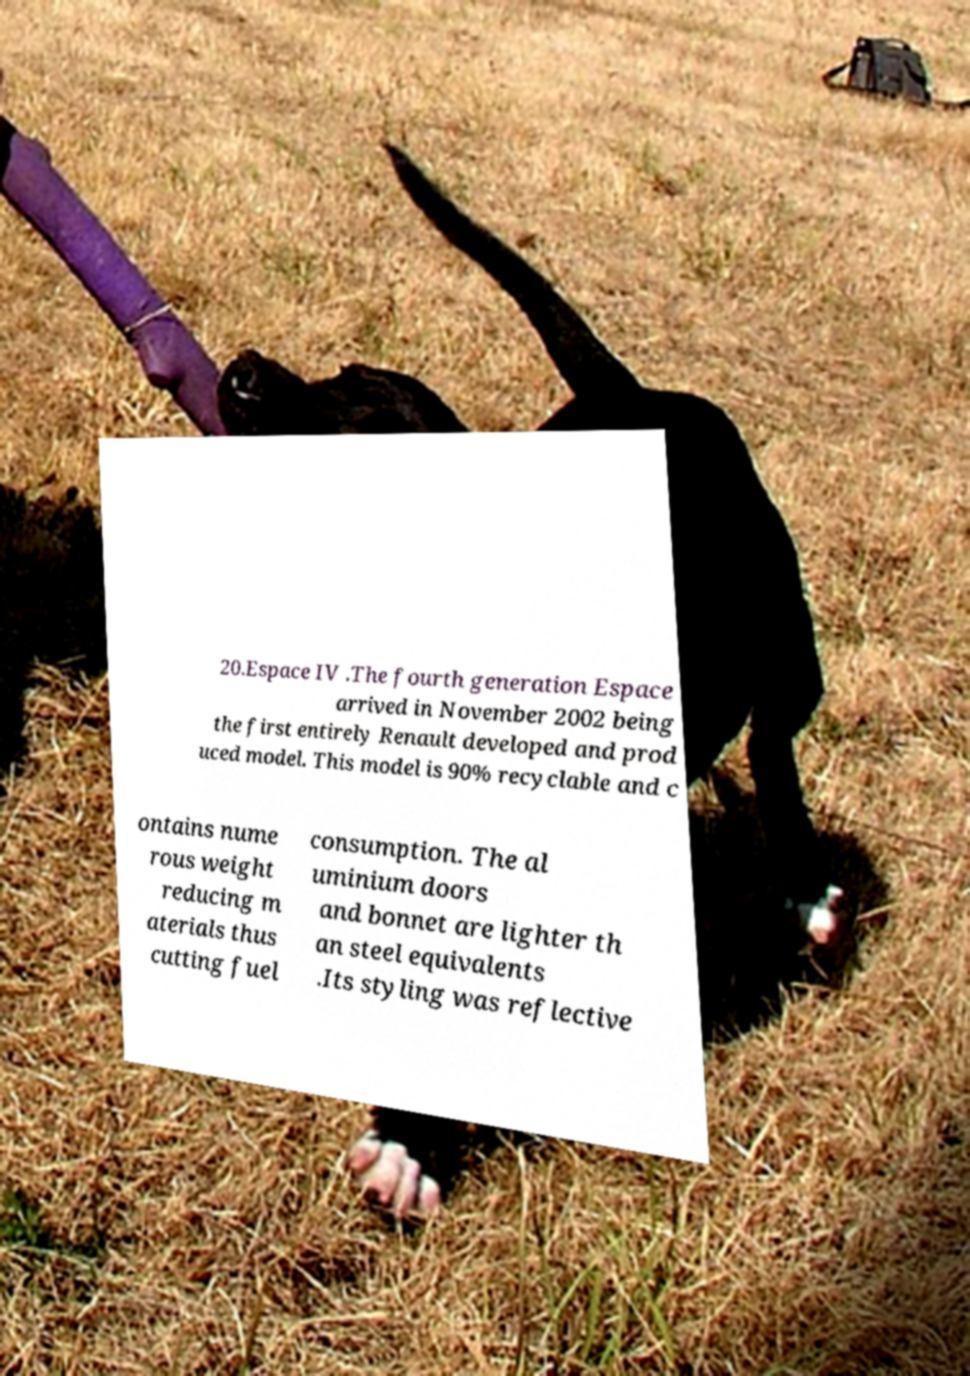Please identify and transcribe the text found in this image. 20.Espace IV .The fourth generation Espace arrived in November 2002 being the first entirely Renault developed and prod uced model. This model is 90% recyclable and c ontains nume rous weight reducing m aterials thus cutting fuel consumption. The al uminium doors and bonnet are lighter th an steel equivalents .Its styling was reflective 